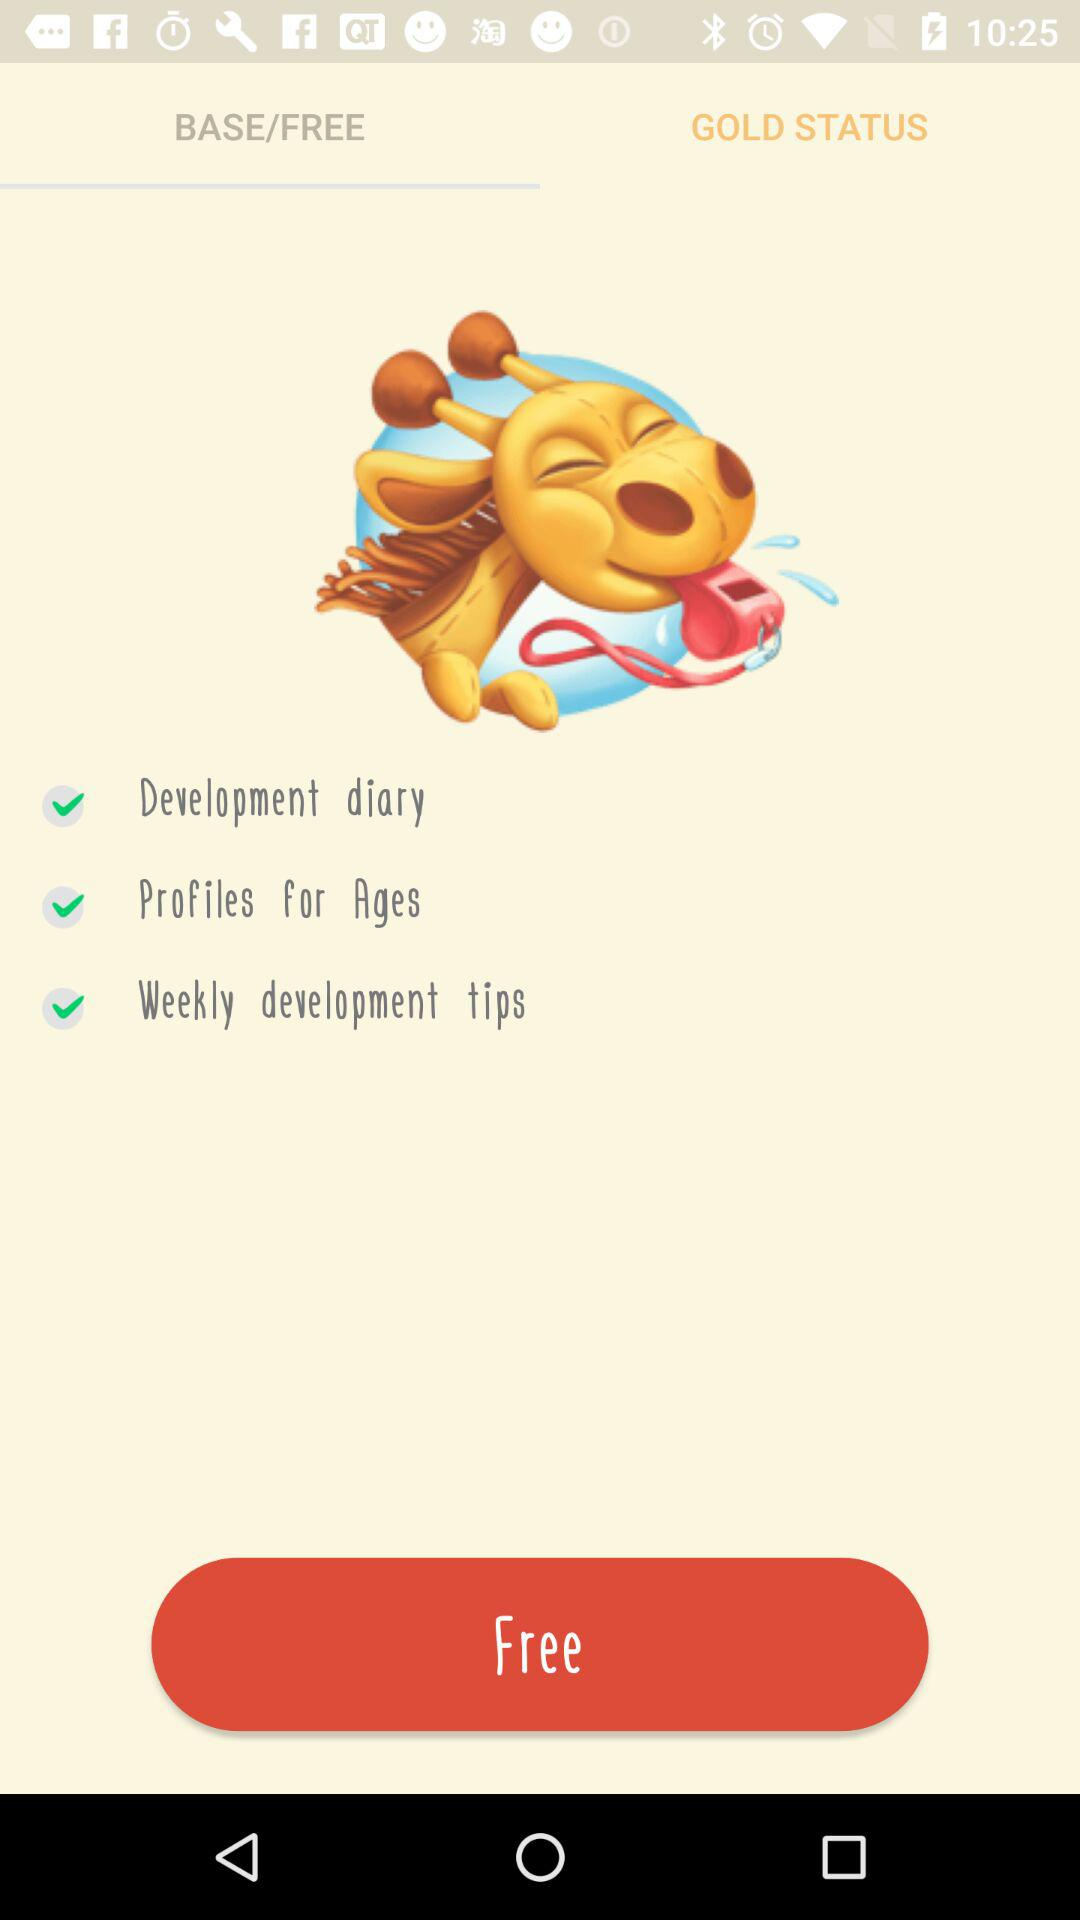What's the weekly tips about?
When the provided information is insufficient, respond with <no answer>. <no answer> 